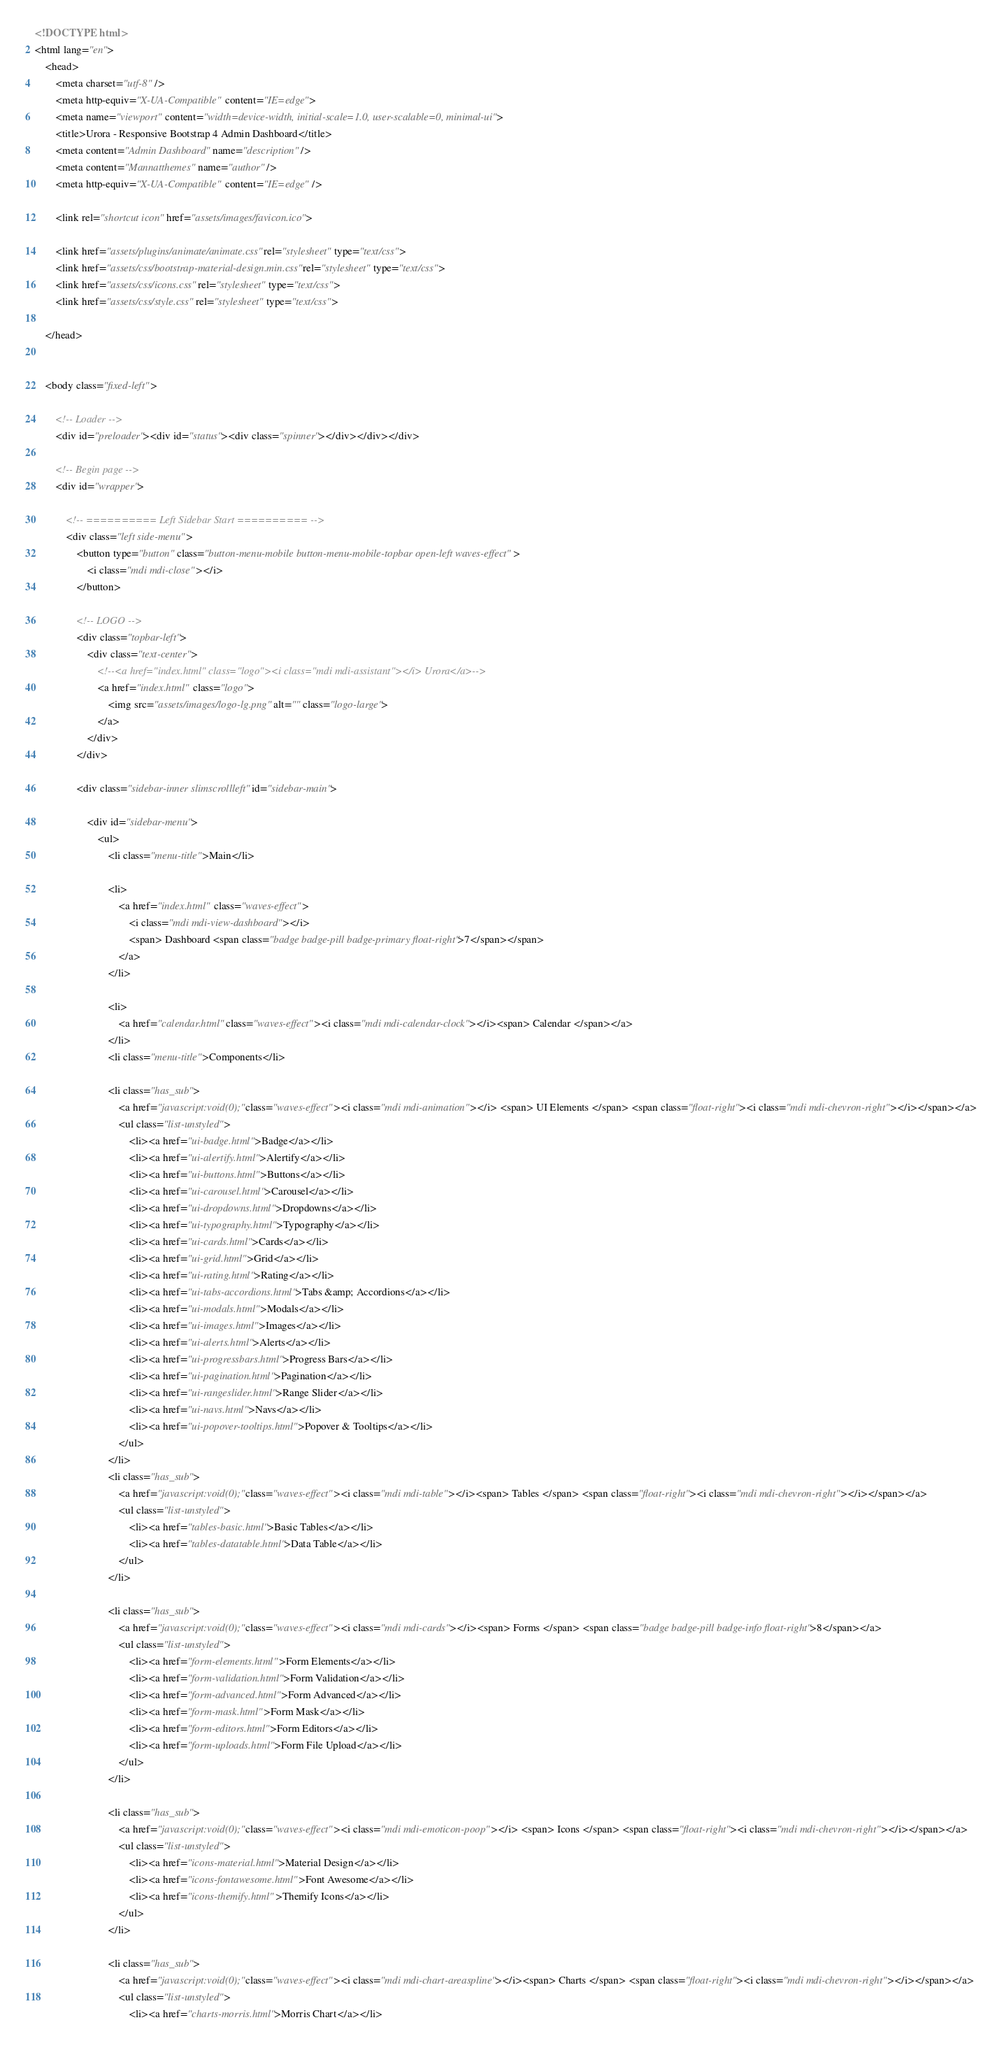Convert code to text. <code><loc_0><loc_0><loc_500><loc_500><_HTML_><!DOCTYPE html>
<html lang="en">
    <head>
        <meta charset="utf-8" />
        <meta http-equiv="X-UA-Compatible" content="IE=edge">
        <meta name="viewport" content="width=device-width, initial-scale=1.0, user-scalable=0, minimal-ui">
        <title>Urora - Responsive Bootstrap 4 Admin Dashboard</title>
        <meta content="Admin Dashboard" name="description" />
        <meta content="Mannatthemes" name="author" />
        <meta http-equiv="X-UA-Compatible" content="IE=edge" />

        <link rel="shortcut icon" href="assets/images/favicon.ico">

        <link href="assets/plugins/animate/animate.css" rel="stylesheet" type="text/css">
        <link href="assets/css/bootstrap-material-design.min.css" rel="stylesheet" type="text/css">
        <link href="assets/css/icons.css" rel="stylesheet" type="text/css">
        <link href="assets/css/style.css" rel="stylesheet" type="text/css">

    </head>


    <body class="fixed-left">

        <!-- Loader -->
        <div id="preloader"><div id="status"><div class="spinner"></div></div></div>

        <!-- Begin page -->
        <div id="wrapper">

            <!-- ========== Left Sidebar Start ========== -->
            <div class="left side-menu">
                <button type="button" class="button-menu-mobile button-menu-mobile-topbar open-left waves-effect">
                    <i class="mdi mdi-close"></i>
                </button>

                <!-- LOGO -->
                <div class="topbar-left">
                    <div class="text-center">
                        <!--<a href="index.html" class="logo"><i class="mdi mdi-assistant"></i> Urora</a>-->
                        <a href="index.html" class="logo">
                            <img src="assets/images/logo-lg.png" alt="" class="logo-large">
                        </a>
                    </div>
                </div>

                <div class="sidebar-inner slimscrollleft" id="sidebar-main">

                    <div id="sidebar-menu">
                        <ul>
                            <li class="menu-title">Main</li>

                            <li>
                                <a href="index.html" class="waves-effect">
                                    <i class="mdi mdi-view-dashboard"></i>
                                    <span> Dashboard <span class="badge badge-pill badge-primary float-right">7</span></span>
                                </a>
                            </li>
                            
                            <li>
                                <a href="calendar.html" class="waves-effect"><i class="mdi mdi-calendar-clock"></i><span> Calendar </span></a>
                            </li>
                            <li class="menu-title">Components</li>

                            <li class="has_sub">
                                <a href="javascript:void(0);" class="waves-effect"><i class="mdi mdi-animation"></i> <span> UI Elements </span> <span class="float-right"><i class="mdi mdi-chevron-right"></i></span></a>
                                <ul class="list-unstyled">
                                    <li><a href="ui-badge.html">Badge</a></li>
                                    <li><a href="ui-alertify.html">Alertify</a></li>
                                    <li><a href="ui-buttons.html">Buttons</a></li>
                                    <li><a href="ui-carousel.html">Carousel</a></li>
                                    <li><a href="ui-dropdowns.html">Dropdowns</a></li>
                                    <li><a href="ui-typography.html">Typography</a></li>
                                    <li><a href="ui-cards.html">Cards</a></li>
                                    <li><a href="ui-grid.html">Grid</a></li>
                                    <li><a href="ui-rating.html">Rating</a></li>
                                    <li><a href="ui-tabs-accordions.html">Tabs &amp; Accordions</a></li>
                                    <li><a href="ui-modals.html">Modals</a></li>
                                    <li><a href="ui-images.html">Images</a></li>
                                    <li><a href="ui-alerts.html">Alerts</a></li>
                                    <li><a href="ui-progressbars.html">Progress Bars</a></li>
                                    <li><a href="ui-pagination.html">Pagination</a></li>
                                    <li><a href="ui-rangeslider.html">Range Slider</a></li>
                                    <li><a href="ui-navs.html">Navs</a></li>                                   
                                    <li><a href="ui-popover-tooltips.html">Popover & Tooltips</a></li>
                                </ul>
                            </li>
                            <li class="has_sub">
                                <a href="javascript:void(0);" class="waves-effect"><i class="mdi mdi-table"></i><span> Tables </span> <span class="float-right"><i class="mdi mdi-chevron-right"></i></span></a>
                                <ul class="list-unstyled">
                                    <li><a href="tables-basic.html">Basic Tables</a></li>
                                    <li><a href="tables-datatable.html">Data Table</a></li>
                                </ul>
                            </li>    

                            <li class="has_sub">
                                <a href="javascript:void(0);" class="waves-effect"><i class="mdi mdi-cards"></i><span> Forms </span> <span class="badge badge-pill badge-info float-right">8</span></a>
                                <ul class="list-unstyled">
                                    <li><a href="form-elements.html">Form Elements</a></li>
                                    <li><a href="form-validation.html">Form Validation</a></li>
                                    <li><a href="form-advanced.html">Form Advanced</a></li>
                                    <li><a href="form-mask.html">Form Mask</a></li>
                                    <li><a href="form-editors.html">Form Editors</a></li>
                                    <li><a href="form-uploads.html">Form File Upload</a></li>                                    
                                </ul>
                            </li>

                            <li class="has_sub">
                                <a href="javascript:void(0);" class="waves-effect"><i class="mdi mdi-emoticon-poop"></i> <span> Icons </span> <span class="float-right"><i class="mdi mdi-chevron-right"></i></span></a>
                                <ul class="list-unstyled">
                                    <li><a href="icons-material.html">Material Design</a></li>
                                    <li><a href="icons-fontawesome.html">Font Awesome</a></li>
                                    <li><a href="icons-themify.html">Themify Icons</a></li>
                                </ul>
                            </li>

                            <li class="has_sub">
                                <a href="javascript:void(0);" class="waves-effect"><i class="mdi mdi-chart-areaspline"></i><span> Charts </span> <span class="float-right"><i class="mdi mdi-chevron-right"></i></span></a>
                                <ul class="list-unstyled">
                                    <li><a href="charts-morris.html">Morris Chart</a></li></code> 